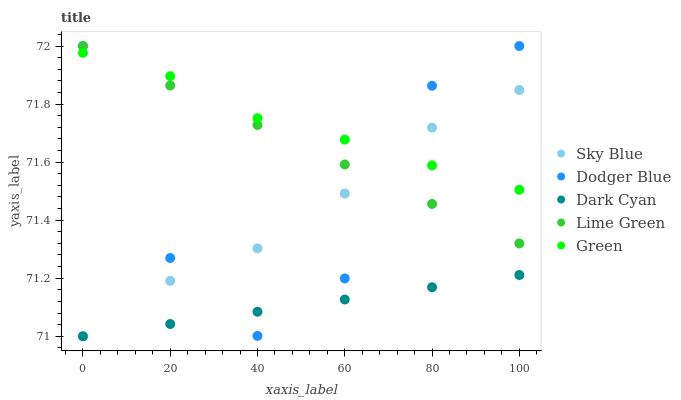Does Dark Cyan have the minimum area under the curve?
Answer yes or no. Yes. Does Green have the maximum area under the curve?
Answer yes or no. Yes. Does Sky Blue have the minimum area under the curve?
Answer yes or no. No. Does Sky Blue have the maximum area under the curve?
Answer yes or no. No. Is Dark Cyan the smoothest?
Answer yes or no. Yes. Is Dodger Blue the roughest?
Answer yes or no. Yes. Is Sky Blue the smoothest?
Answer yes or no. No. Is Sky Blue the roughest?
Answer yes or no. No. Does Dark Cyan have the lowest value?
Answer yes or no. Yes. Does Green have the lowest value?
Answer yes or no. No. Does Lime Green have the highest value?
Answer yes or no. Yes. Does Sky Blue have the highest value?
Answer yes or no. No. Is Dark Cyan less than Lime Green?
Answer yes or no. Yes. Is Lime Green greater than Dark Cyan?
Answer yes or no. Yes. Does Lime Green intersect Green?
Answer yes or no. Yes. Is Lime Green less than Green?
Answer yes or no. No. Is Lime Green greater than Green?
Answer yes or no. No. Does Dark Cyan intersect Lime Green?
Answer yes or no. No. 